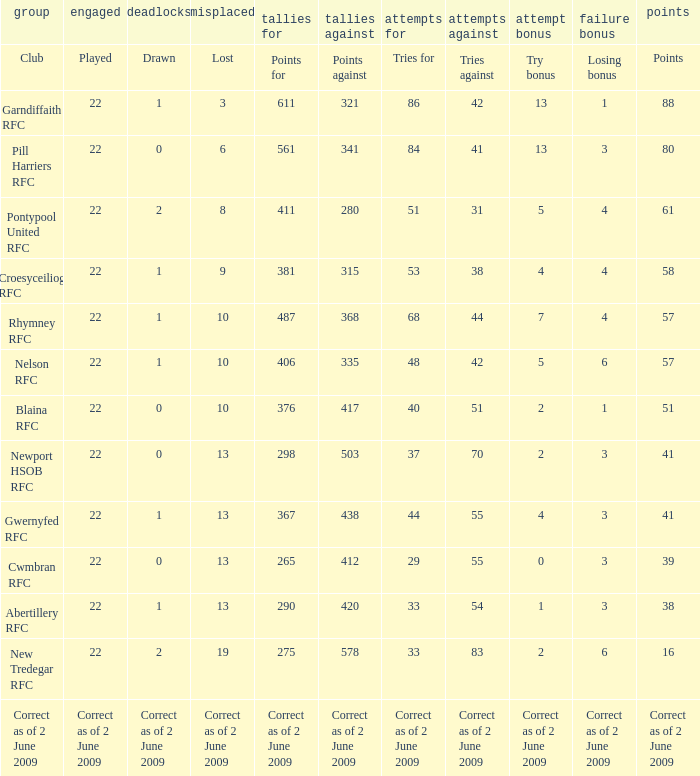How many tries against did the club with 1 drawn and 41 points have? 55.0. 